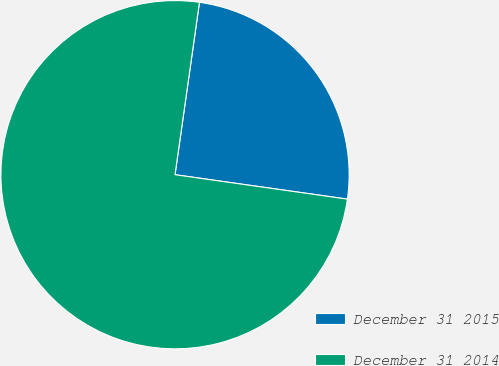Convert chart. <chart><loc_0><loc_0><loc_500><loc_500><pie_chart><fcel>December 31 2015<fcel>December 31 2014<nl><fcel>25.0%<fcel>75.0%<nl></chart> 